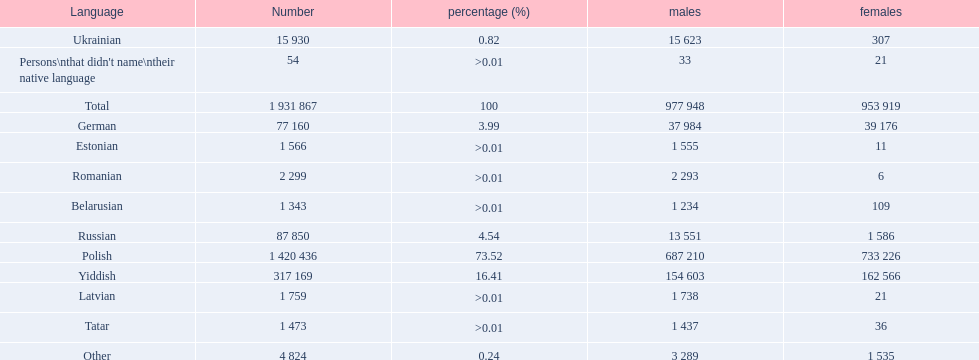What languages are spoken in the warsaw governorate? Polish, Yiddish, Russian, German, Ukrainian, Romanian, Latvian, Estonian, Tatar, Belarusian, Other, Persons\nthat didn't name\ntheir native language. What is the number for russian? 87 850. On this list what is the next lowest number? 77 160. Which language has a number of 77160 speakers? German. 